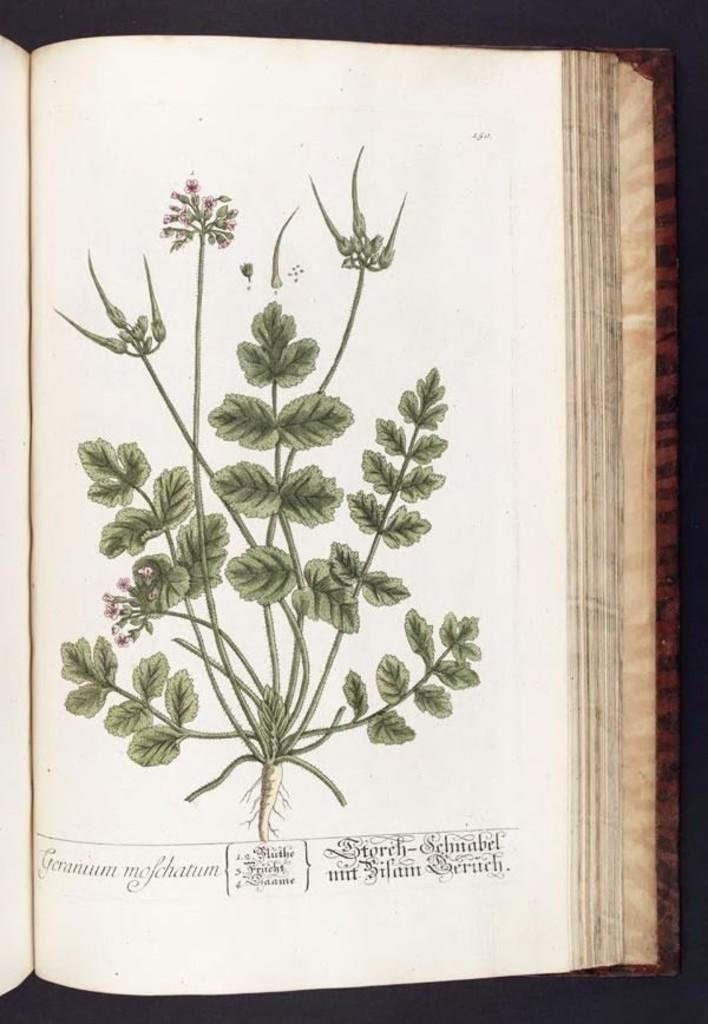What is the main subject of the image? There is an opened book in the image. What is depicted in the illustration within the book? The book contains an illustration of a plant. Can you describe the plant in the illustration? The plant has leaves, stems, flowers, and roots. Is there any text visible in the image? Yes, there is text visible at the bottom of the image. How many volleyballs are being used to form the plant illustration in the image? There are no volleyballs present in the image; the illustration depicts a plant with leaves, stems, flowers, and roots. What type of rake is shown interacting with the plant illustration in the image? There is no rake present in the image; the illustration only shows the plant and its components. 